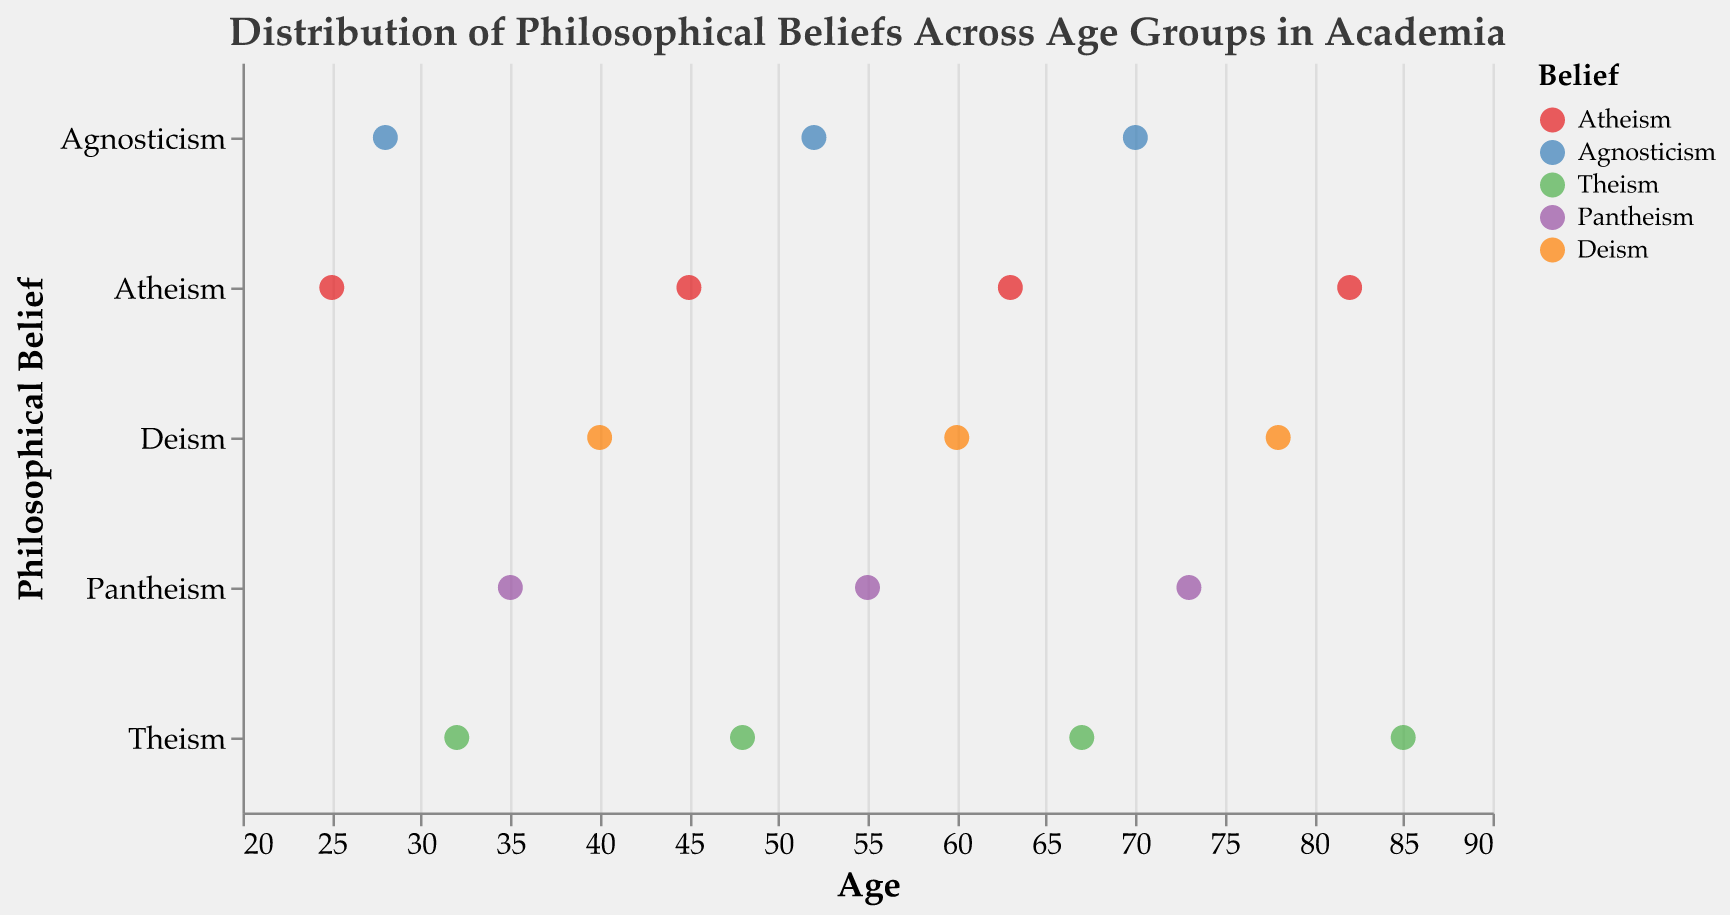What is the title of the plot? The title is located at the top of the plot and is displayed in a larger font size. It reads "Distribution of Philosophical Beliefs Across Age Groups in Academia".
Answer: Distribution of Philosophical Beliefs Across Age Groups in Academia How many data points represent Atheism? Locate the points in the plot corresponding to Atheism on the y-axis. Count these points manually. There are four points (at ages 25, 45, 63, and 82).
Answer: 4 Which belief is associated with the oldest philosopher, and what is their age? Identify the data point with the highest age value, which is 85. Hover over this point or refer to the tooltip to find that the belief is Theism. The philosopher's name is also accessible but not needed for the answer.
Answer: Theism What is the average age of philosophers who adhere to Deism? Identify the ages of philosophers who hold Deism (40, 60, 78). Add these ages (40 + 60 + 78) and then divide by the number of data points (3). The calculation is (40 + 60 + 78) / 3 = 178 / 3 ≈ 59.33.
Answer: 59.33 Compare the age ranges of philosophers with Atheism and Theism beliefs. Which group has the wider age range? Identify the ages for Atheism (25, 45, 63, 82) and Theism (32, 48, 67, 85). Calculate the range for each belief: Atheism (82-25 = 57), Theism (85-32= 53). Compare the two ranges.
Answer: Atheism Which philosophical belief appears most frequently among philosophers between the ages of 50 and 70? Identify the philosophers within the age range 50 to 70. The belief of these philosophers are Agnosticism (52, 70) and Theism (67). Agnosticism appears twice, and Theism appears once.
Answer: Agnosticism What is the distribution of Agnosticism across the age groups? Identify the ages corresponding to Agnosticism (28, 52, 70). The data points are at these ages.
Answer: 28, 52, 70 Which age group has the most diverse range of beliefs? Look for age ranges where the greatest number of different beliefs appear. Ages between 60 to 63 show Atheism (63), Theism (67), and Agnosticism (70).
Answer: 60-70 What is the youngest age at which a philosopher holds Pantheism? Identify the lowest age for the belief Pantheism (35, 55, 73). The lowest age is 35.
Answer: 35 How many philosophers are associated with each belief? Count the number of data points for each belief by looking at the y-axis categories. Atheism (4), Agnosticism (3), Theism (4), Pantheism (3), and Deism (3).
Answer: Atheism: 4, Agnosticism: 3, Theism: 4, Pantheism: 3, Deism: 3 